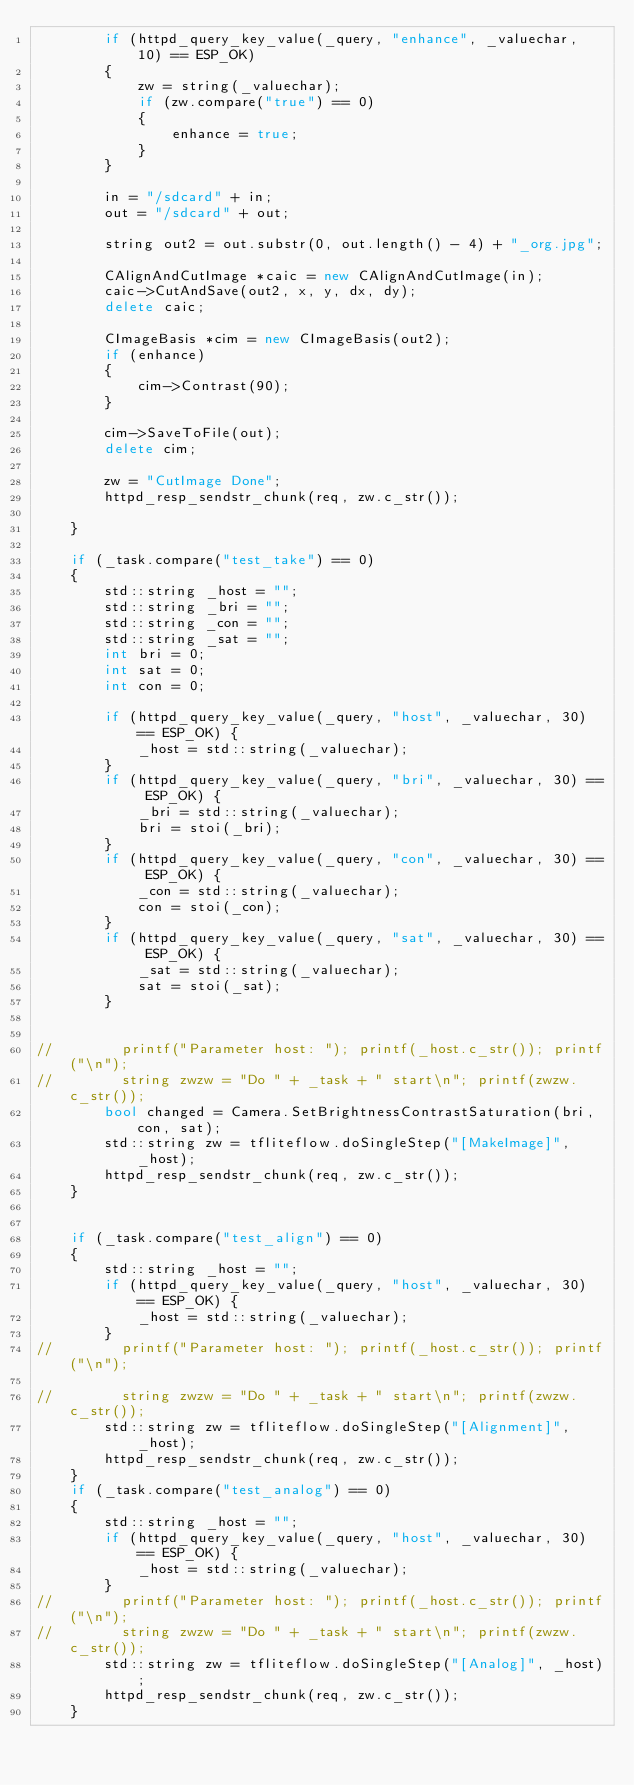<code> <loc_0><loc_0><loc_500><loc_500><_C++_>        if (httpd_query_key_value(_query, "enhance", _valuechar, 10) == ESP_OK)
        {
            zw = string(_valuechar);
            if (zw.compare("true") == 0)
            {
                enhance = true;
            }
        }

        in = "/sdcard" + in;
        out = "/sdcard" + out;

        string out2 = out.substr(0, out.length() - 4) + "_org.jpg";

        CAlignAndCutImage *caic = new CAlignAndCutImage(in);
        caic->CutAndSave(out2, x, y, dx, dy);
        delete caic;    

        CImageBasis *cim = new CImageBasis(out2);
        if (enhance)
        {
            cim->Contrast(90);
        }

        cim->SaveToFile(out);
        delete cim;        

        zw = "CutImage Done";
        httpd_resp_sendstr_chunk(req, zw.c_str()); 
        
    }

    if (_task.compare("test_take") == 0)
    {
        std::string _host = "";
        std::string _bri = "";
        std::string _con = "";
        std::string _sat = "";
        int bri = 0;
        int sat = 0;
        int con = 0;

        if (httpd_query_key_value(_query, "host", _valuechar, 30) == ESP_OK) {
            _host = std::string(_valuechar);
        }
        if (httpd_query_key_value(_query, "bri", _valuechar, 30) == ESP_OK) {
            _bri = std::string(_valuechar);
            bri = stoi(_bri);
        }
        if (httpd_query_key_value(_query, "con", _valuechar, 30) == ESP_OK) {
            _con = std::string(_valuechar);
            con = stoi(_con);
        }
        if (httpd_query_key_value(_query, "sat", _valuechar, 30) == ESP_OK) {
            _sat = std::string(_valuechar);
            sat = stoi(_sat);
        }


//        printf("Parameter host: "); printf(_host.c_str()); printf("\n"); 
//        string zwzw = "Do " + _task + " start\n"; printf(zwzw.c_str());
        bool changed = Camera.SetBrightnessContrastSaturation(bri, con, sat);
        std::string zw = tfliteflow.doSingleStep("[MakeImage]", _host);
        httpd_resp_sendstr_chunk(req, zw.c_str()); 
    } 


    if (_task.compare("test_align") == 0)
    {
        std::string _host = "";
        if (httpd_query_key_value(_query, "host", _valuechar, 30) == ESP_OK) {
            _host = std::string(_valuechar);
        }
//        printf("Parameter host: "); printf(_host.c_str()); printf("\n"); 

//        string zwzw = "Do " + _task + " start\n"; printf(zwzw.c_str());
        std::string zw = tfliteflow.doSingleStep("[Alignment]", _host);
        httpd_resp_sendstr_chunk(req, zw.c_str()); 
    }  
    if (_task.compare("test_analog") == 0)
    {
        std::string _host = "";
        if (httpd_query_key_value(_query, "host", _valuechar, 30) == ESP_OK) {
            _host = std::string(_valuechar);
        }
//        printf("Parameter host: "); printf(_host.c_str()); printf("\n"); 
//        string zwzw = "Do " + _task + " start\n"; printf(zwzw.c_str());
        std::string zw = tfliteflow.doSingleStep("[Analog]", _host);
        httpd_resp_sendstr_chunk(req, zw.c_str()); 
    }  </code> 